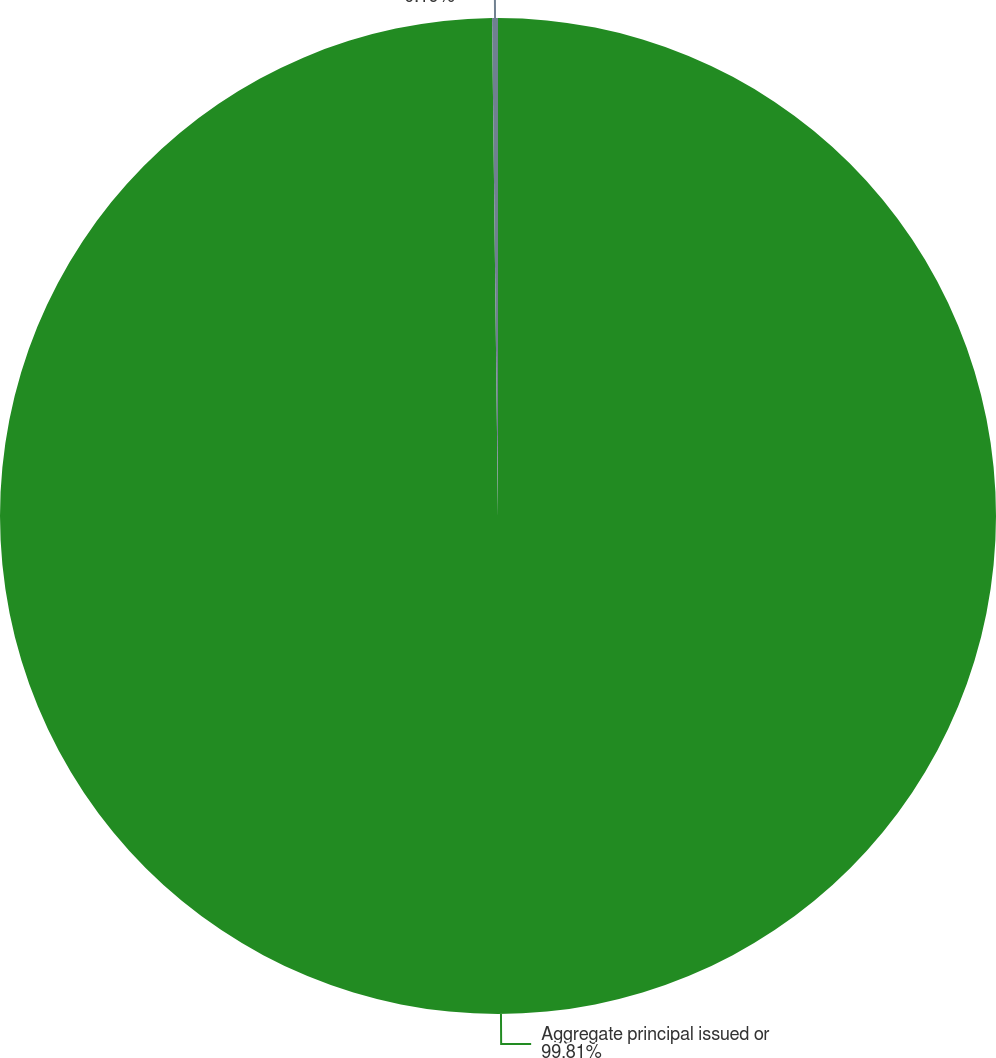<chart> <loc_0><loc_0><loc_500><loc_500><pie_chart><fcel>Aggregate principal issued or<fcel>LIBOR margin<nl><fcel>99.81%<fcel>0.19%<nl></chart> 